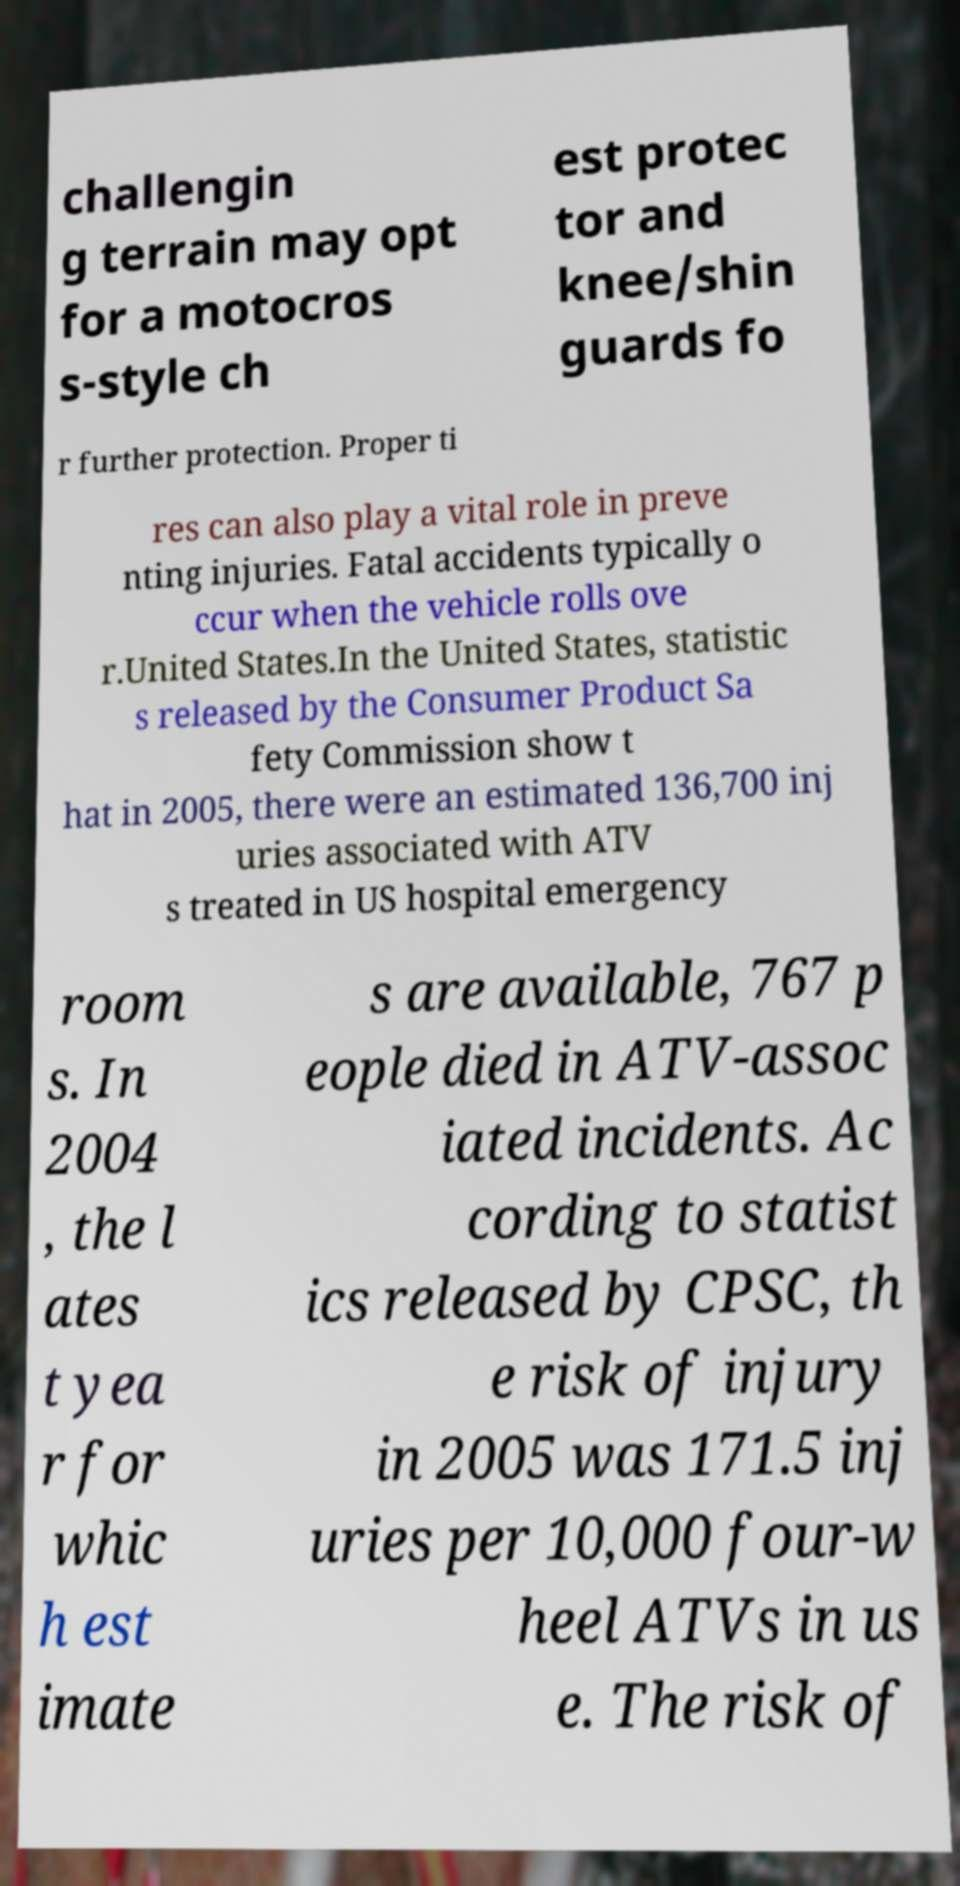Could you assist in decoding the text presented in this image and type it out clearly? challengin g terrain may opt for a motocros s-style ch est protec tor and knee/shin guards fo r further protection. Proper ti res can also play a vital role in preve nting injuries. Fatal accidents typically o ccur when the vehicle rolls ove r.United States.In the United States, statistic s released by the Consumer Product Sa fety Commission show t hat in 2005, there were an estimated 136,700 inj uries associated with ATV s treated in US hospital emergency room s. In 2004 , the l ates t yea r for whic h est imate s are available, 767 p eople died in ATV-assoc iated incidents. Ac cording to statist ics released by CPSC, th e risk of injury in 2005 was 171.5 inj uries per 10,000 four-w heel ATVs in us e. The risk of 